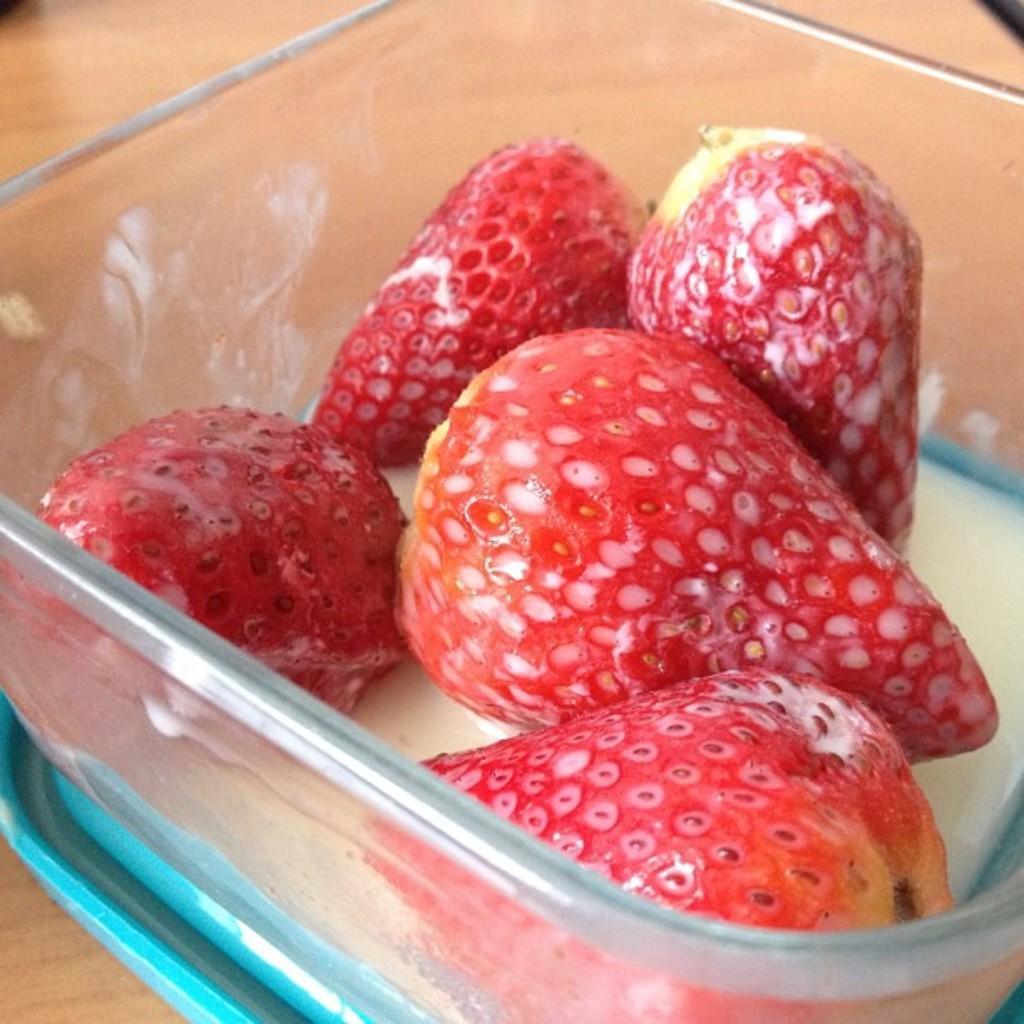Describe this image in one or two sentences. In this image, we can see a strawberry container. 